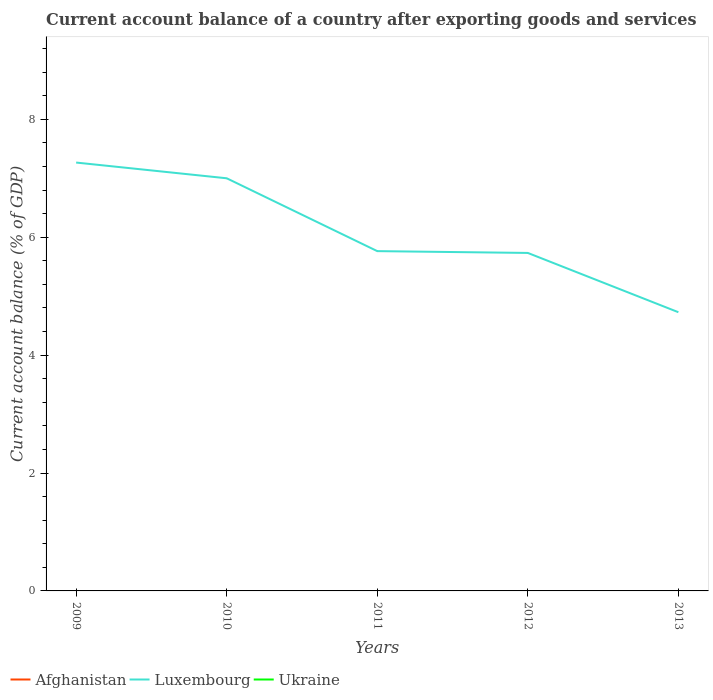How many different coloured lines are there?
Provide a short and direct response. 1. Does the line corresponding to Afghanistan intersect with the line corresponding to Luxembourg?
Keep it short and to the point. No. Is the number of lines equal to the number of legend labels?
Your response must be concise. No. Across all years, what is the maximum account balance in Luxembourg?
Give a very brief answer. 4.73. What is the total account balance in Luxembourg in the graph?
Your response must be concise. 0.03. What is the difference between the highest and the second highest account balance in Luxembourg?
Keep it short and to the point. 2.54. How many lines are there?
Offer a terse response. 1. Where does the legend appear in the graph?
Offer a very short reply. Bottom left. How are the legend labels stacked?
Your response must be concise. Horizontal. What is the title of the graph?
Keep it short and to the point. Current account balance of a country after exporting goods and services. Does "Seychelles" appear as one of the legend labels in the graph?
Offer a terse response. No. What is the label or title of the X-axis?
Your answer should be compact. Years. What is the label or title of the Y-axis?
Offer a very short reply. Current account balance (% of GDP). What is the Current account balance (% of GDP) in Luxembourg in 2009?
Your answer should be compact. 7.27. What is the Current account balance (% of GDP) of Ukraine in 2009?
Ensure brevity in your answer.  0. What is the Current account balance (% of GDP) of Afghanistan in 2010?
Offer a very short reply. 0. What is the Current account balance (% of GDP) of Luxembourg in 2010?
Provide a succinct answer. 7. What is the Current account balance (% of GDP) in Ukraine in 2010?
Provide a short and direct response. 0. What is the Current account balance (% of GDP) in Afghanistan in 2011?
Provide a short and direct response. 0. What is the Current account balance (% of GDP) in Luxembourg in 2011?
Ensure brevity in your answer.  5.76. What is the Current account balance (% of GDP) of Ukraine in 2011?
Provide a succinct answer. 0. What is the Current account balance (% of GDP) in Afghanistan in 2012?
Your answer should be very brief. 0. What is the Current account balance (% of GDP) of Luxembourg in 2012?
Provide a short and direct response. 5.73. What is the Current account balance (% of GDP) in Afghanistan in 2013?
Ensure brevity in your answer.  0. What is the Current account balance (% of GDP) in Luxembourg in 2013?
Make the answer very short. 4.73. What is the Current account balance (% of GDP) in Ukraine in 2013?
Your response must be concise. 0. Across all years, what is the maximum Current account balance (% of GDP) in Luxembourg?
Your answer should be very brief. 7.27. Across all years, what is the minimum Current account balance (% of GDP) in Luxembourg?
Provide a succinct answer. 4.73. What is the total Current account balance (% of GDP) in Luxembourg in the graph?
Give a very brief answer. 30.49. What is the difference between the Current account balance (% of GDP) of Luxembourg in 2009 and that in 2010?
Offer a terse response. 0.27. What is the difference between the Current account balance (% of GDP) of Luxembourg in 2009 and that in 2011?
Provide a succinct answer. 1.5. What is the difference between the Current account balance (% of GDP) of Luxembourg in 2009 and that in 2012?
Ensure brevity in your answer.  1.53. What is the difference between the Current account balance (% of GDP) in Luxembourg in 2009 and that in 2013?
Your response must be concise. 2.54. What is the difference between the Current account balance (% of GDP) of Luxembourg in 2010 and that in 2011?
Make the answer very short. 1.24. What is the difference between the Current account balance (% of GDP) of Luxembourg in 2010 and that in 2012?
Offer a very short reply. 1.27. What is the difference between the Current account balance (% of GDP) in Luxembourg in 2010 and that in 2013?
Provide a short and direct response. 2.27. What is the difference between the Current account balance (% of GDP) of Luxembourg in 2011 and that in 2012?
Keep it short and to the point. 0.03. What is the difference between the Current account balance (% of GDP) of Luxembourg in 2011 and that in 2013?
Make the answer very short. 1.04. What is the difference between the Current account balance (% of GDP) of Luxembourg in 2012 and that in 2013?
Give a very brief answer. 1.01. What is the average Current account balance (% of GDP) of Luxembourg per year?
Ensure brevity in your answer.  6.1. What is the ratio of the Current account balance (% of GDP) of Luxembourg in 2009 to that in 2010?
Offer a very short reply. 1.04. What is the ratio of the Current account balance (% of GDP) of Luxembourg in 2009 to that in 2011?
Ensure brevity in your answer.  1.26. What is the ratio of the Current account balance (% of GDP) in Luxembourg in 2009 to that in 2012?
Keep it short and to the point. 1.27. What is the ratio of the Current account balance (% of GDP) of Luxembourg in 2009 to that in 2013?
Your answer should be compact. 1.54. What is the ratio of the Current account balance (% of GDP) of Luxembourg in 2010 to that in 2011?
Keep it short and to the point. 1.21. What is the ratio of the Current account balance (% of GDP) in Luxembourg in 2010 to that in 2012?
Offer a very short reply. 1.22. What is the ratio of the Current account balance (% of GDP) in Luxembourg in 2010 to that in 2013?
Make the answer very short. 1.48. What is the ratio of the Current account balance (% of GDP) in Luxembourg in 2011 to that in 2012?
Offer a terse response. 1.01. What is the ratio of the Current account balance (% of GDP) of Luxembourg in 2011 to that in 2013?
Give a very brief answer. 1.22. What is the ratio of the Current account balance (% of GDP) of Luxembourg in 2012 to that in 2013?
Provide a short and direct response. 1.21. What is the difference between the highest and the second highest Current account balance (% of GDP) of Luxembourg?
Your answer should be very brief. 0.27. What is the difference between the highest and the lowest Current account balance (% of GDP) in Luxembourg?
Make the answer very short. 2.54. 